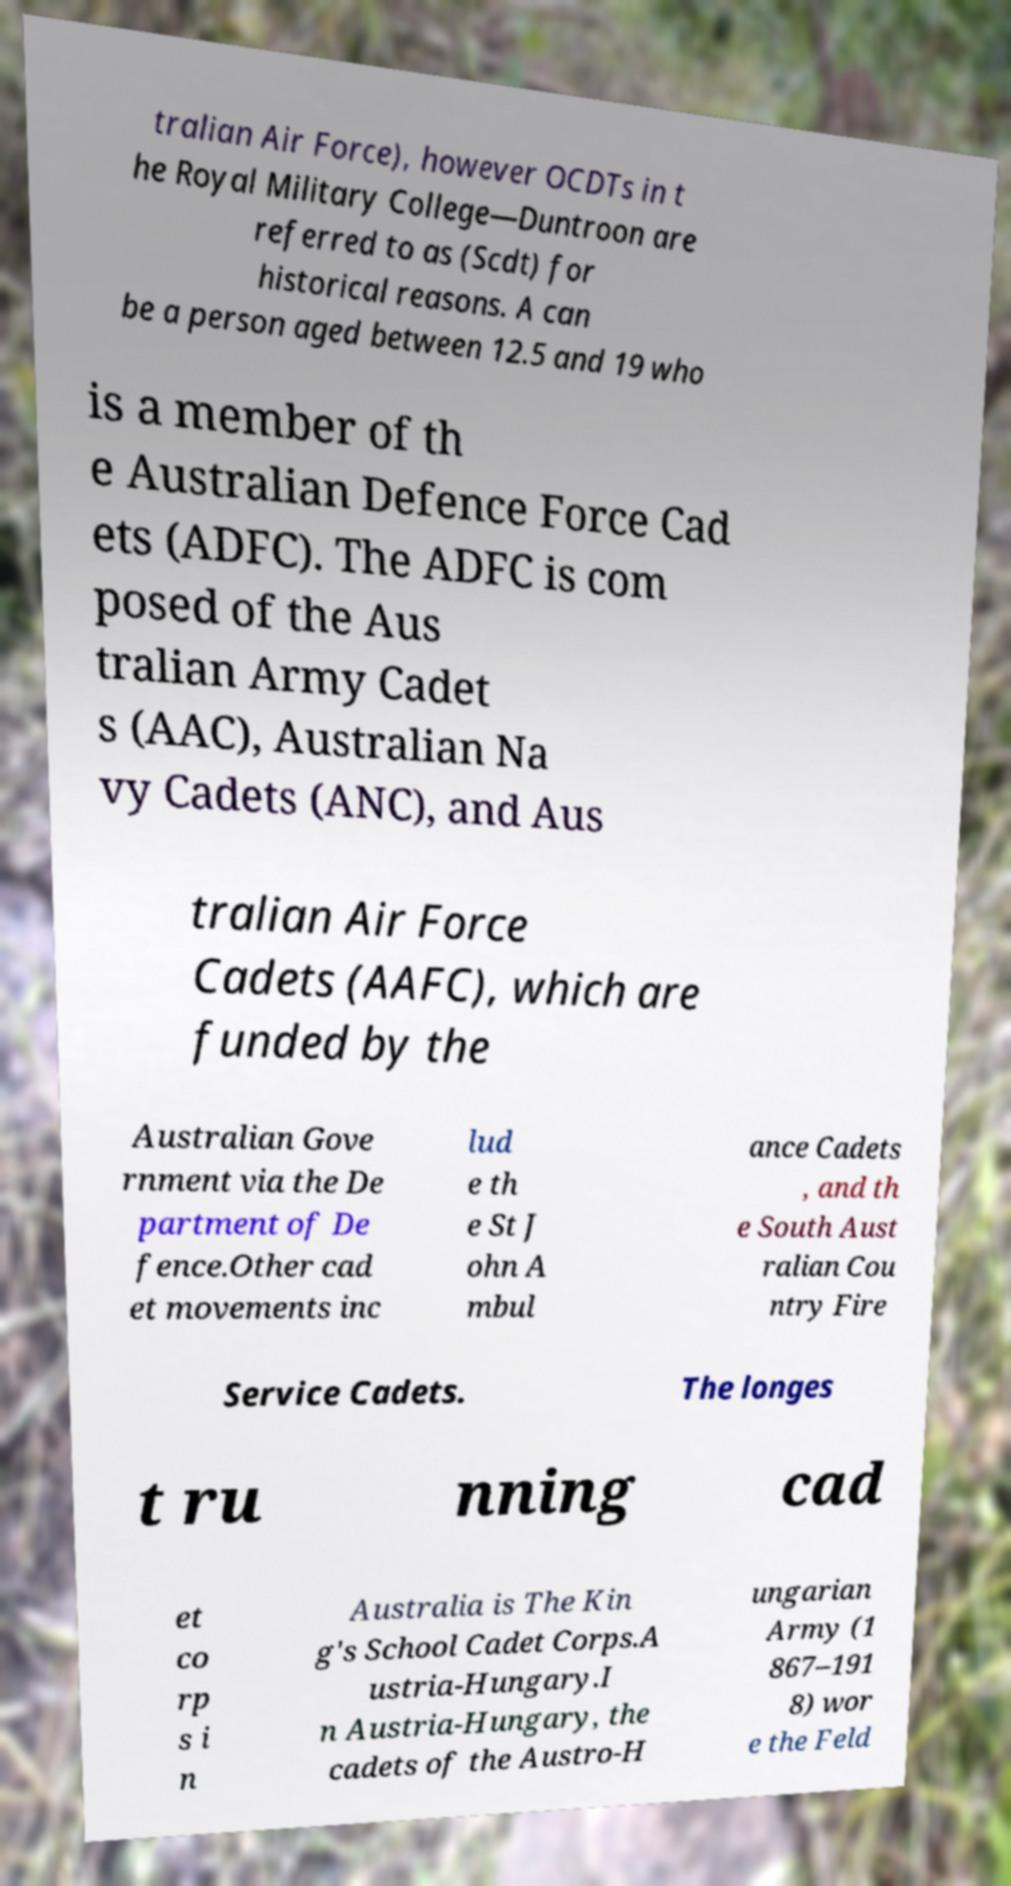Please read and relay the text visible in this image. What does it say? tralian Air Force), however OCDTs in t he Royal Military College—Duntroon are referred to as (Scdt) for historical reasons. A can be a person aged between 12.5 and 19 who is a member of th e Australian Defence Force Cad ets (ADFC). The ADFC is com posed of the Aus tralian Army Cadet s (AAC), Australian Na vy Cadets (ANC), and Aus tralian Air Force Cadets (AAFC), which are funded by the Australian Gove rnment via the De partment of De fence.Other cad et movements inc lud e th e St J ohn A mbul ance Cadets , and th e South Aust ralian Cou ntry Fire Service Cadets. The longes t ru nning cad et co rp s i n Australia is The Kin g's School Cadet Corps.A ustria-Hungary.I n Austria-Hungary, the cadets of the Austro-H ungarian Army (1 867–191 8) wor e the Feld 